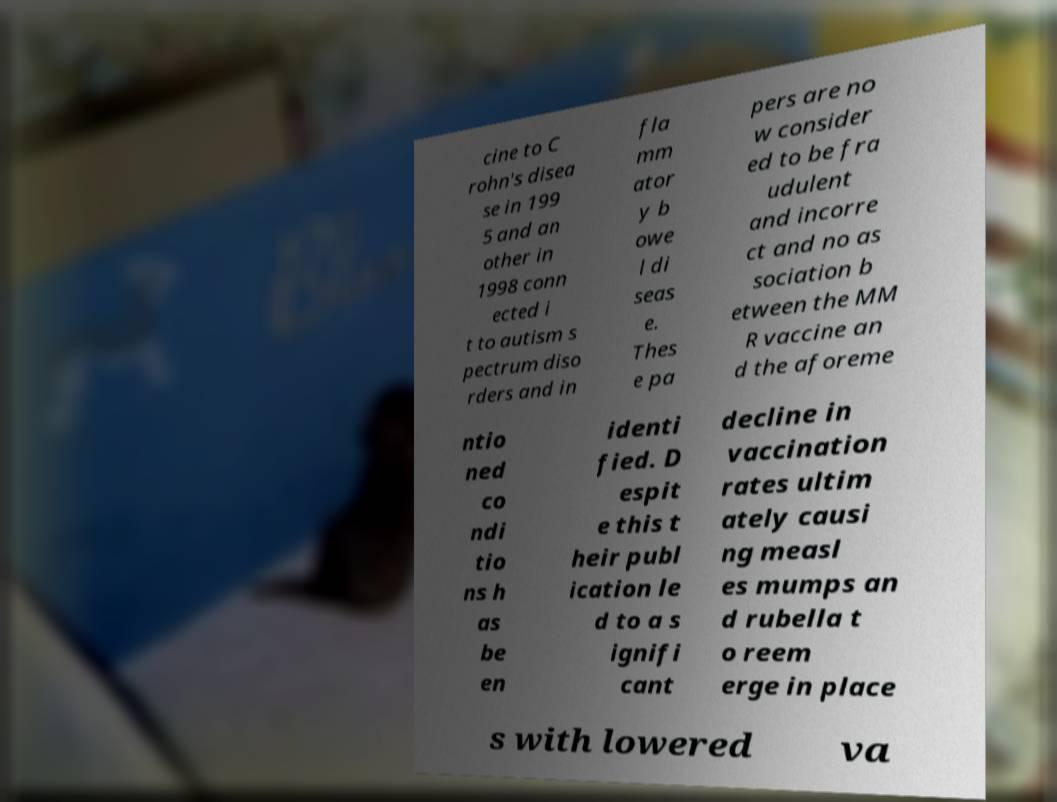I need the written content from this picture converted into text. Can you do that? cine to C rohn's disea se in 199 5 and an other in 1998 conn ected i t to autism s pectrum diso rders and in fla mm ator y b owe l di seas e. Thes e pa pers are no w consider ed to be fra udulent and incorre ct and no as sociation b etween the MM R vaccine an d the aforeme ntio ned co ndi tio ns h as be en identi fied. D espit e this t heir publ ication le d to a s ignifi cant decline in vaccination rates ultim ately causi ng measl es mumps an d rubella t o reem erge in place s with lowered va 